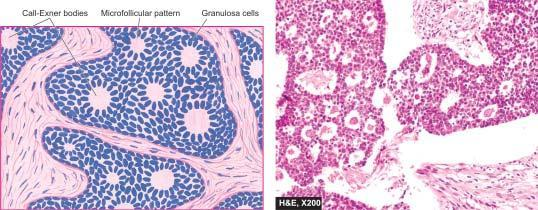how did granulosa cell tumour show uniform granulosa cells and numerous rosette-like call-exner bodies?
Answer the question using a single word or phrase. By granulosa cells 